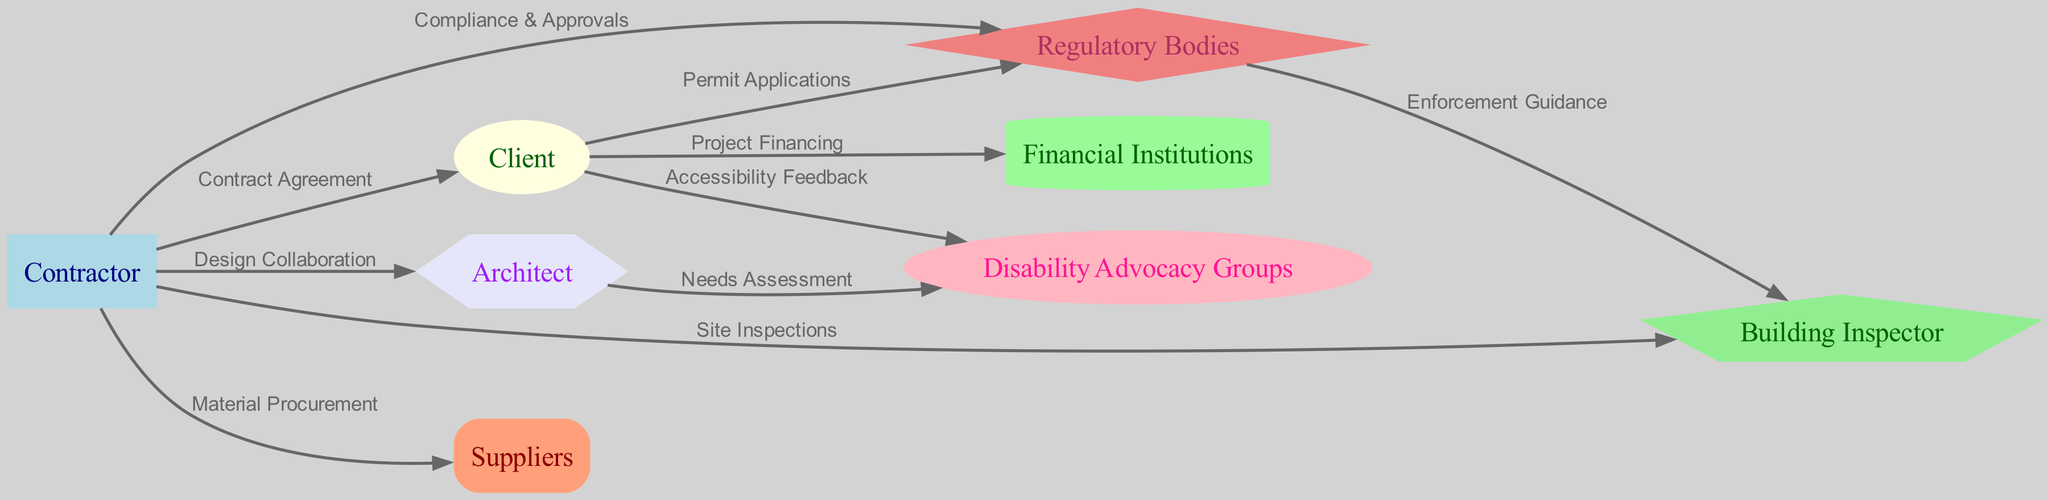What are the two main stakeholders in this diagram? The two main stakeholders prominently indicated in the diagram are the Contractor and the Client, as they have direct relationships shown through various edges connecting them in the network.
Answer: Contractor and Client How many nodes are present in the diagram? By counting all individual entities listed in the "nodes" section, we identify a total of eight distinct nodes in the diagram.
Answer: 8 What type of relationship connects the Contractor and Client? The relationship connecting the Contractor and Client is labeled as "Contract Agreement," which implies formal contractual interactions between the two.
Answer: Contract Agreement Which group provides "Enforcement Guidance"? The edges indicate that the Regulatory Bodies provide "Enforcement Guidance" as their relationship with the Building Inspector is clearly labeled in the diagram, linking the two entities.
Answer: Regulatory Bodies How many edges are there between the Client and Disability Advocacy Groups? There is one direct edge indicated in the diagram between the Client and Disability Advocacy Groups, labeled as "Accessibility Feedback," which shows their interaction.
Answer: 1 What is the role of the Building Inspector in this context? The Building Inspector's role is to conduct "Site Inspections," ensuring that the construction work meets the necessary guidelines and standards outlined by the Regulatory Bodies.
Answer: Site Inspections Who is responsible for "Needs Assessment"? According to the diagram, the Architect is noted as responsible for conducting "Needs Assessment," indicating their role in identifying necessary features for accessibility.
Answer: Architect Which entities collaborate on "Design Collaboration"? The Contractor collaborates with the Architect on "Design Collaboration," as this relationship is directly indicated by one of the edges in the diagram.
Answer: Contractor and Architect What do clients apply for concerning the Regulatory Bodies? Clients apply for "Permit Applications" to the Regulatory Bodies as indicated in the edges, demonstrating the procedural aspects involved in obtaining permissions for the retrofitting projects.
Answer: Permit Applications 